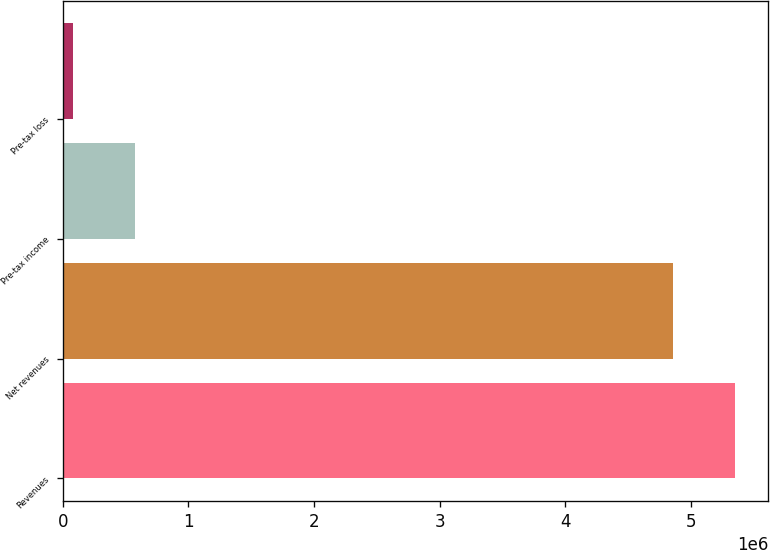<chart> <loc_0><loc_0><loc_500><loc_500><bar_chart><fcel>Revenues<fcel>Net revenues<fcel>Pre-tax income<fcel>Pre-tax loss<nl><fcel>5.34952e+06<fcel>4.86137e+06<fcel>572072<fcel>83918<nl></chart> 